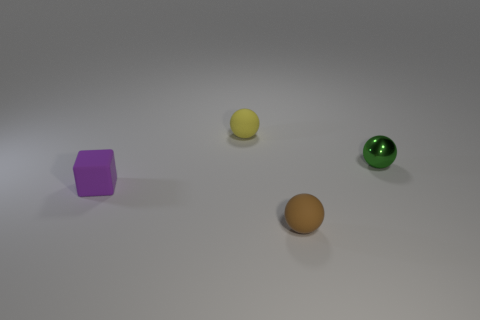What number of other things are the same color as the tiny cube?
Ensure brevity in your answer.  0. Is the shape of the tiny rubber object behind the purple matte thing the same as  the tiny metal object?
Your answer should be compact. Yes. Is the number of small purple blocks on the left side of the green metallic thing less than the number of tiny brown matte balls?
Your response must be concise. No. How many large yellow metal things are there?
Offer a terse response. 0. The matte thing on the right side of the small rubber ball behind the tiny purple thing is what shape?
Offer a terse response. Sphere. There is a purple rubber thing; how many small metal objects are behind it?
Offer a very short reply. 1. Are the small purple object and the thing right of the tiny brown matte ball made of the same material?
Offer a terse response. No. Are there any gray metallic objects of the same size as the cube?
Keep it short and to the point. No. Are there the same number of green metallic things that are left of the cube and yellow rubber spheres?
Keep it short and to the point. No. The shiny sphere has what size?
Offer a terse response. Small. 